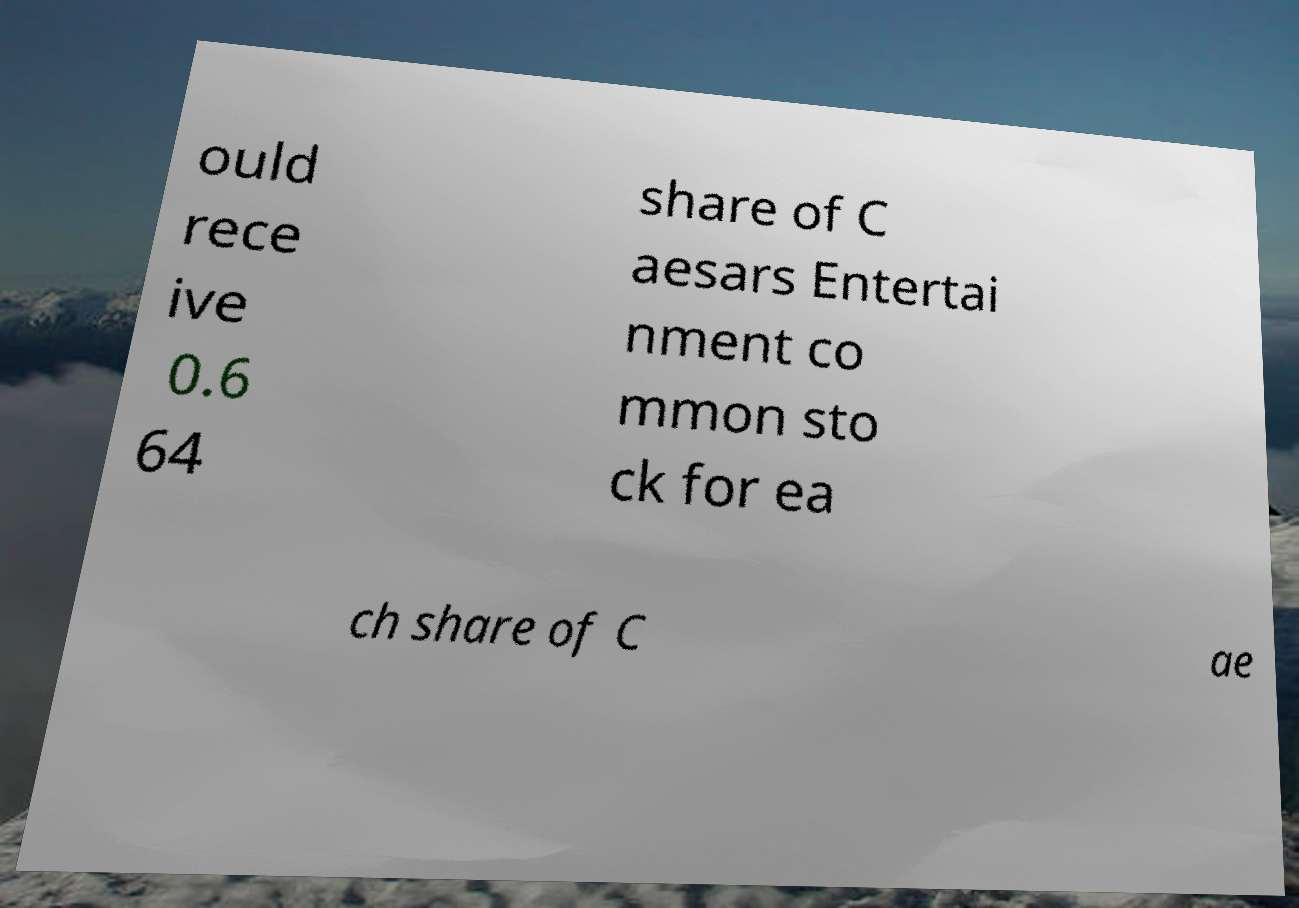Could you extract and type out the text from this image? ould rece ive 0.6 64 share of C aesars Entertai nment co mmon sto ck for ea ch share of C ae 